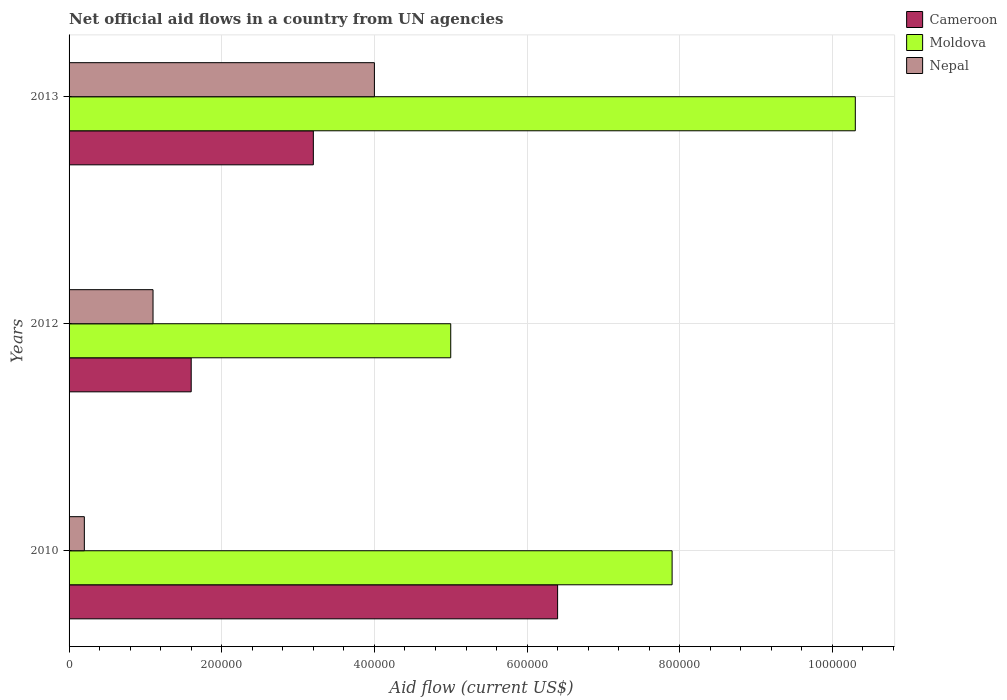How many groups of bars are there?
Your answer should be compact. 3. Are the number of bars per tick equal to the number of legend labels?
Provide a short and direct response. Yes. How many bars are there on the 1st tick from the bottom?
Your answer should be very brief. 3. What is the label of the 3rd group of bars from the top?
Offer a very short reply. 2010. In how many cases, is the number of bars for a given year not equal to the number of legend labels?
Offer a terse response. 0. What is the net official aid flow in Cameroon in 2013?
Provide a short and direct response. 3.20e+05. Across all years, what is the maximum net official aid flow in Moldova?
Offer a very short reply. 1.03e+06. Across all years, what is the minimum net official aid flow in Cameroon?
Your answer should be very brief. 1.60e+05. In which year was the net official aid flow in Moldova maximum?
Your answer should be very brief. 2013. In which year was the net official aid flow in Cameroon minimum?
Offer a terse response. 2012. What is the total net official aid flow in Moldova in the graph?
Your response must be concise. 2.32e+06. What is the difference between the net official aid flow in Nepal in 2012 and that in 2013?
Make the answer very short. -2.90e+05. What is the difference between the net official aid flow in Nepal in 2010 and the net official aid flow in Moldova in 2013?
Provide a short and direct response. -1.01e+06. What is the average net official aid flow in Cameroon per year?
Your answer should be very brief. 3.73e+05. In the year 2010, what is the difference between the net official aid flow in Moldova and net official aid flow in Nepal?
Provide a succinct answer. 7.70e+05. Is the net official aid flow in Cameroon in 2010 less than that in 2013?
Your answer should be compact. No. What is the difference between the highest and the second highest net official aid flow in Nepal?
Ensure brevity in your answer.  2.90e+05. What is the difference between the highest and the lowest net official aid flow in Cameroon?
Provide a succinct answer. 4.80e+05. What does the 1st bar from the top in 2010 represents?
Keep it short and to the point. Nepal. What does the 2nd bar from the bottom in 2012 represents?
Make the answer very short. Moldova. Are all the bars in the graph horizontal?
Keep it short and to the point. Yes. How many years are there in the graph?
Your response must be concise. 3. What is the difference between two consecutive major ticks on the X-axis?
Your answer should be compact. 2.00e+05. Are the values on the major ticks of X-axis written in scientific E-notation?
Your answer should be very brief. No. Does the graph contain any zero values?
Your answer should be compact. No. Does the graph contain grids?
Offer a very short reply. Yes. What is the title of the graph?
Keep it short and to the point. Net official aid flows in a country from UN agencies. What is the Aid flow (current US$) in Cameroon in 2010?
Provide a short and direct response. 6.40e+05. What is the Aid flow (current US$) in Moldova in 2010?
Provide a succinct answer. 7.90e+05. What is the Aid flow (current US$) of Moldova in 2012?
Your answer should be compact. 5.00e+05. What is the Aid flow (current US$) in Cameroon in 2013?
Your response must be concise. 3.20e+05. What is the Aid flow (current US$) in Moldova in 2013?
Your answer should be very brief. 1.03e+06. Across all years, what is the maximum Aid flow (current US$) of Cameroon?
Make the answer very short. 6.40e+05. Across all years, what is the maximum Aid flow (current US$) of Moldova?
Offer a terse response. 1.03e+06. Across all years, what is the minimum Aid flow (current US$) in Moldova?
Your answer should be compact. 5.00e+05. What is the total Aid flow (current US$) in Cameroon in the graph?
Your response must be concise. 1.12e+06. What is the total Aid flow (current US$) in Moldova in the graph?
Offer a very short reply. 2.32e+06. What is the total Aid flow (current US$) in Nepal in the graph?
Your answer should be compact. 5.30e+05. What is the difference between the Aid flow (current US$) of Nepal in 2010 and that in 2012?
Give a very brief answer. -9.00e+04. What is the difference between the Aid flow (current US$) of Cameroon in 2010 and that in 2013?
Provide a succinct answer. 3.20e+05. What is the difference between the Aid flow (current US$) in Nepal in 2010 and that in 2013?
Ensure brevity in your answer.  -3.80e+05. What is the difference between the Aid flow (current US$) of Cameroon in 2012 and that in 2013?
Provide a succinct answer. -1.60e+05. What is the difference between the Aid flow (current US$) of Moldova in 2012 and that in 2013?
Give a very brief answer. -5.30e+05. What is the difference between the Aid flow (current US$) in Cameroon in 2010 and the Aid flow (current US$) in Nepal in 2012?
Offer a very short reply. 5.30e+05. What is the difference between the Aid flow (current US$) of Moldova in 2010 and the Aid flow (current US$) of Nepal in 2012?
Provide a succinct answer. 6.80e+05. What is the difference between the Aid flow (current US$) of Cameroon in 2010 and the Aid flow (current US$) of Moldova in 2013?
Your response must be concise. -3.90e+05. What is the difference between the Aid flow (current US$) in Cameroon in 2012 and the Aid flow (current US$) in Moldova in 2013?
Provide a succinct answer. -8.70e+05. What is the average Aid flow (current US$) in Cameroon per year?
Your answer should be very brief. 3.73e+05. What is the average Aid flow (current US$) of Moldova per year?
Your answer should be very brief. 7.73e+05. What is the average Aid flow (current US$) in Nepal per year?
Your answer should be very brief. 1.77e+05. In the year 2010, what is the difference between the Aid flow (current US$) of Cameroon and Aid flow (current US$) of Moldova?
Provide a succinct answer. -1.50e+05. In the year 2010, what is the difference between the Aid flow (current US$) of Cameroon and Aid flow (current US$) of Nepal?
Keep it short and to the point. 6.20e+05. In the year 2010, what is the difference between the Aid flow (current US$) in Moldova and Aid flow (current US$) in Nepal?
Your answer should be compact. 7.70e+05. In the year 2012, what is the difference between the Aid flow (current US$) of Cameroon and Aid flow (current US$) of Moldova?
Keep it short and to the point. -3.40e+05. In the year 2013, what is the difference between the Aid flow (current US$) in Cameroon and Aid flow (current US$) in Moldova?
Keep it short and to the point. -7.10e+05. In the year 2013, what is the difference between the Aid flow (current US$) of Cameroon and Aid flow (current US$) of Nepal?
Offer a terse response. -8.00e+04. In the year 2013, what is the difference between the Aid flow (current US$) of Moldova and Aid flow (current US$) of Nepal?
Make the answer very short. 6.30e+05. What is the ratio of the Aid flow (current US$) in Moldova in 2010 to that in 2012?
Keep it short and to the point. 1.58. What is the ratio of the Aid flow (current US$) of Nepal in 2010 to that in 2012?
Provide a short and direct response. 0.18. What is the ratio of the Aid flow (current US$) of Cameroon in 2010 to that in 2013?
Your answer should be compact. 2. What is the ratio of the Aid flow (current US$) of Moldova in 2010 to that in 2013?
Your answer should be compact. 0.77. What is the ratio of the Aid flow (current US$) in Moldova in 2012 to that in 2013?
Ensure brevity in your answer.  0.49. What is the ratio of the Aid flow (current US$) in Nepal in 2012 to that in 2013?
Make the answer very short. 0.28. What is the difference between the highest and the second highest Aid flow (current US$) in Cameroon?
Ensure brevity in your answer.  3.20e+05. What is the difference between the highest and the lowest Aid flow (current US$) of Cameroon?
Provide a short and direct response. 4.80e+05. What is the difference between the highest and the lowest Aid flow (current US$) of Moldova?
Give a very brief answer. 5.30e+05. What is the difference between the highest and the lowest Aid flow (current US$) of Nepal?
Offer a very short reply. 3.80e+05. 